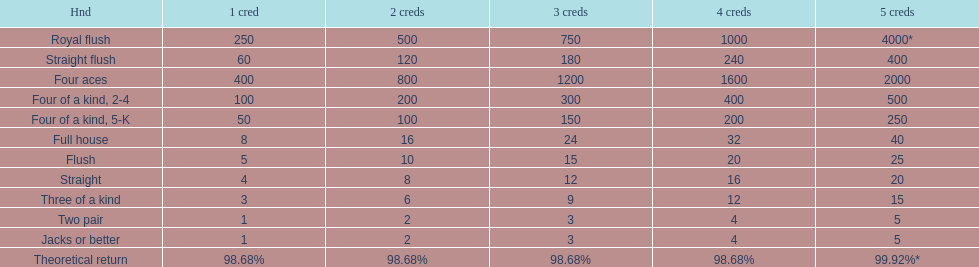How many straight wins at 3 credits equals one straight flush win at two credits? 10. 